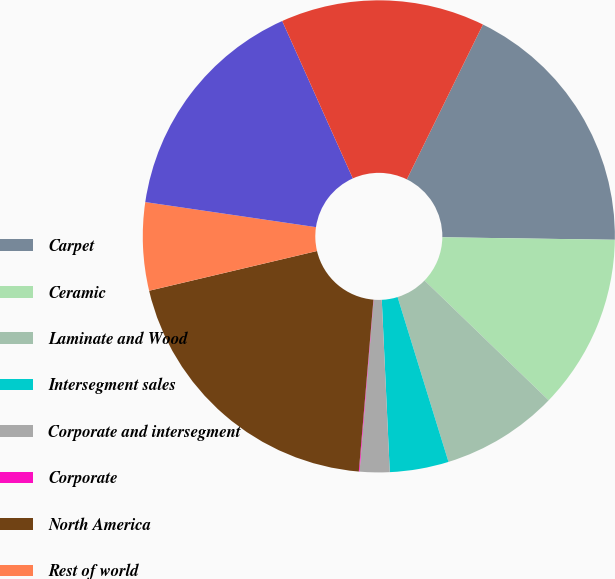<chart> <loc_0><loc_0><loc_500><loc_500><pie_chart><fcel>Carpet<fcel>Ceramic<fcel>Laminate and Wood<fcel>Intersegment sales<fcel>Corporate and intersegment<fcel>Corporate<fcel>North America<fcel>Rest of world<fcel>Soft surface<fcel>Tile<nl><fcel>17.96%<fcel>11.99%<fcel>8.01%<fcel>4.03%<fcel>2.04%<fcel>0.05%<fcel>19.95%<fcel>6.02%<fcel>15.97%<fcel>13.98%<nl></chart> 